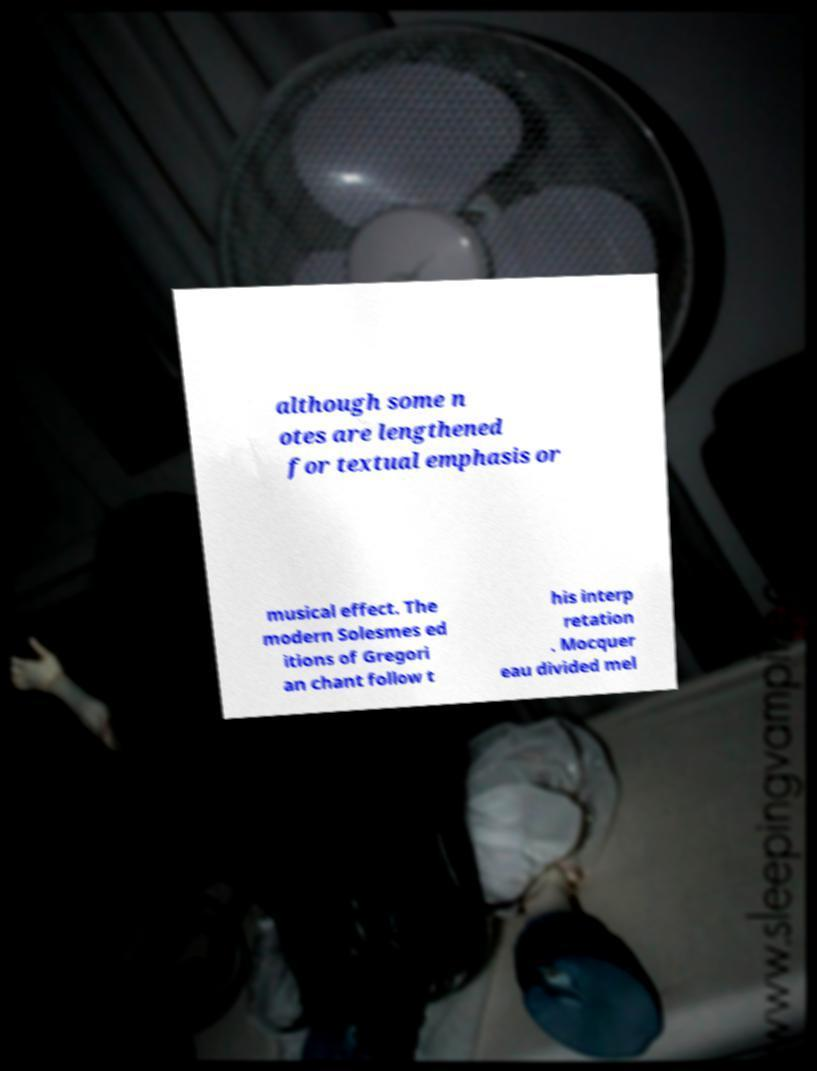Could you assist in decoding the text presented in this image and type it out clearly? although some n otes are lengthened for textual emphasis or musical effect. The modern Solesmes ed itions of Gregori an chant follow t his interp retation . Mocquer eau divided mel 